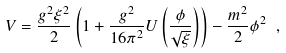Convert formula to latex. <formula><loc_0><loc_0><loc_500><loc_500>V = \frac { g ^ { 2 } \xi ^ { 2 } } { 2 } \left ( 1 + \frac { g ^ { 2 } } { 1 6 \pi ^ { 2 } } U \left ( \frac { \phi } { \sqrt { \xi } } \right ) \right ) - \frac { m ^ { 2 } } { 2 } \phi ^ { 2 } \ ,</formula> 